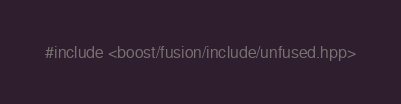Convert code to text. <code><loc_0><loc_0><loc_500><loc_500><_C++_>#include <boost/fusion/include/unfused.hpp>
</code> 